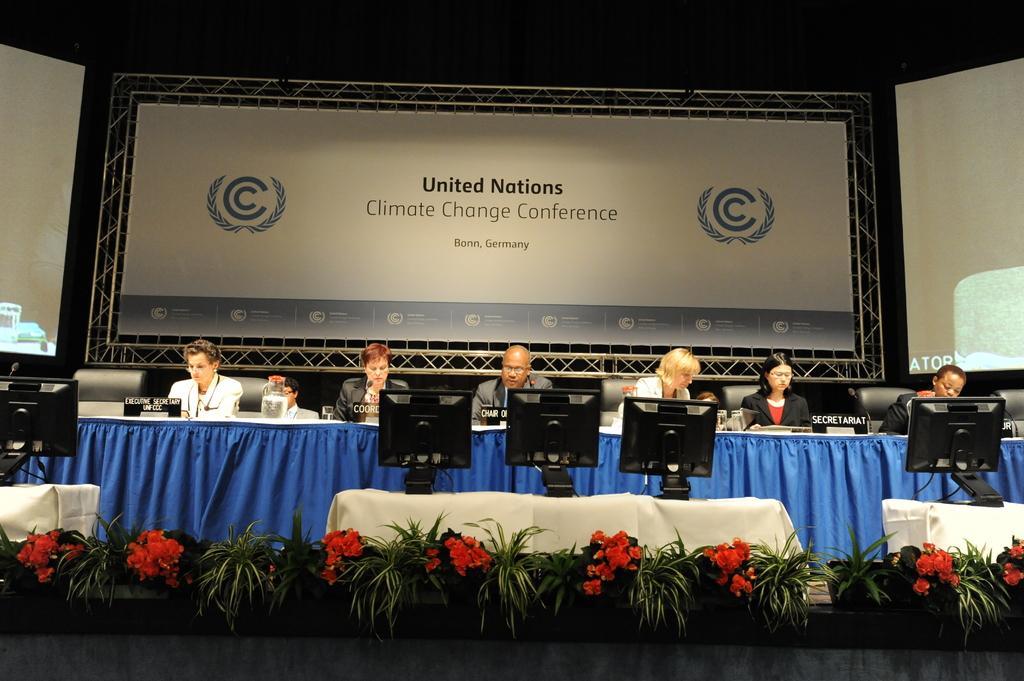In one or two sentences, can you explain what this image depicts? In this image we can see few persons sitting on chairs. In front of the persons we can see few objects on the table. There are monitors on the table. At the bottom we can see plants and flowers. Behind the persons we can see a board with text. On both sides of the image we can see the screens. 